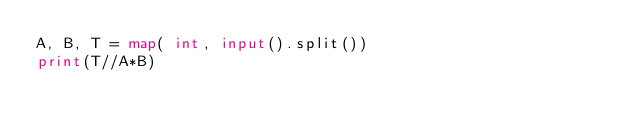<code> <loc_0><loc_0><loc_500><loc_500><_Python_>A, B, T = map( int, input().split())
print(T//A*B)</code> 